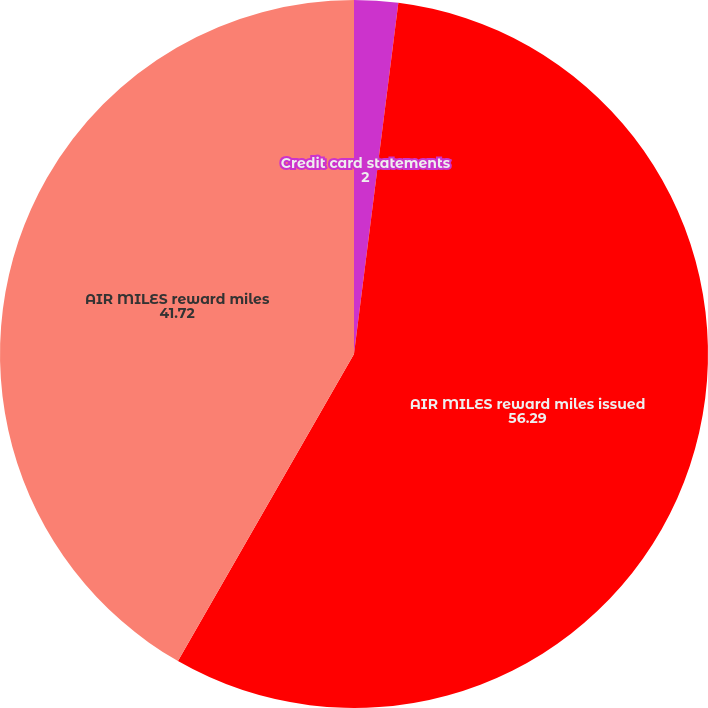Convert chart to OTSL. <chart><loc_0><loc_0><loc_500><loc_500><pie_chart><fcel>Credit card statements<fcel>AIR MILES reward miles issued<fcel>AIR MILES reward miles<nl><fcel>2.0%<fcel>56.29%<fcel>41.72%<nl></chart> 